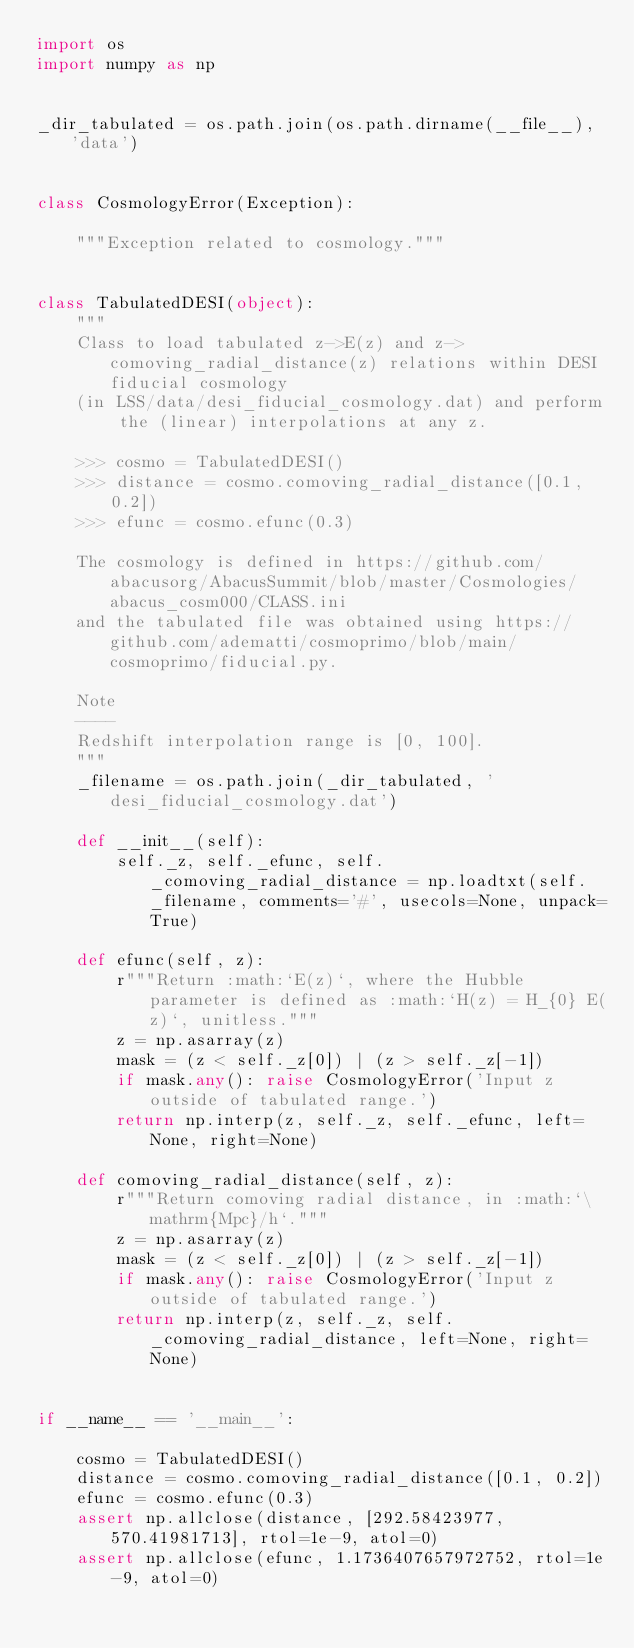Convert code to text. <code><loc_0><loc_0><loc_500><loc_500><_Python_>import os
import numpy as np


_dir_tabulated = os.path.join(os.path.dirname(__file__), 'data')


class CosmologyError(Exception):

    """Exception related to cosmology."""


class TabulatedDESI(object):
    """
    Class to load tabulated z->E(z) and z->comoving_radial_distance(z) relations within DESI fiducial cosmology
    (in LSS/data/desi_fiducial_cosmology.dat) and perform the (linear) interpolations at any z.

    >>> cosmo = TabulatedDESI()
    >>> distance = cosmo.comoving_radial_distance([0.1, 0.2])
    >>> efunc = cosmo.efunc(0.3)

    The cosmology is defined in https://github.com/abacusorg/AbacusSummit/blob/master/Cosmologies/abacus_cosm000/CLASS.ini
    and the tabulated file was obtained using https://github.com/adematti/cosmoprimo/blob/main/cosmoprimo/fiducial.py.

    Note
    ----
    Redshift interpolation range is [0, 100].
    """
    _filename = os.path.join(_dir_tabulated, 'desi_fiducial_cosmology.dat')

    def __init__(self):
        self._z, self._efunc, self._comoving_radial_distance = np.loadtxt(self._filename, comments='#', usecols=None, unpack=True)

    def efunc(self, z):
        r"""Return :math:`E(z)`, where the Hubble parameter is defined as :math:`H(z) = H_{0} E(z)`, unitless."""
        z = np.asarray(z)
        mask = (z < self._z[0]) | (z > self._z[-1])
        if mask.any(): raise CosmologyError('Input z outside of tabulated range.')
        return np.interp(z, self._z, self._efunc, left=None, right=None)

    def comoving_radial_distance(self, z):
        r"""Return comoving radial distance, in :math:`\mathrm{Mpc}/h`."""
        z = np.asarray(z)
        mask = (z < self._z[0]) | (z > self._z[-1])
        if mask.any(): raise CosmologyError('Input z outside of tabulated range.')
        return np.interp(z, self._z, self._comoving_radial_distance, left=None, right=None)


if __name__ == '__main__':

    cosmo = TabulatedDESI()
    distance = cosmo.comoving_radial_distance([0.1, 0.2])
    efunc = cosmo.efunc(0.3)
    assert np.allclose(distance, [292.58423977, 570.41981713], rtol=1e-9, atol=0)
    assert np.allclose(efunc, 1.1736407657972752, rtol=1e-9, atol=0)</code> 